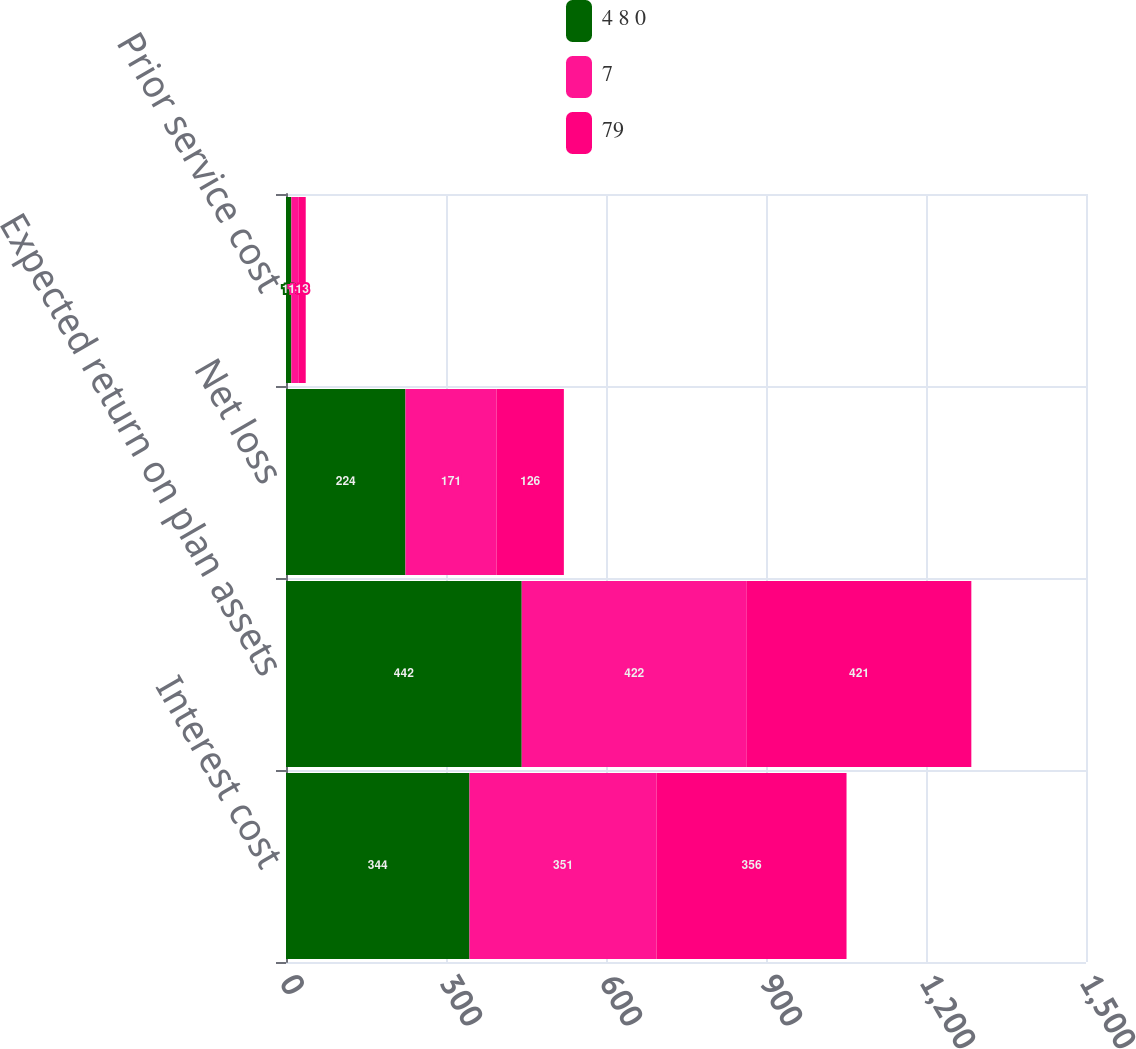Convert chart. <chart><loc_0><loc_0><loc_500><loc_500><stacked_bar_chart><ecel><fcel>Interest cost<fcel>Expected return on plan assets<fcel>Net loss<fcel>Prior service cost<nl><fcel>4 8 0<fcel>344<fcel>442<fcel>224<fcel>10<nl><fcel>7<fcel>351<fcel>422<fcel>171<fcel>14<nl><fcel>79<fcel>356<fcel>421<fcel>126<fcel>13<nl></chart> 